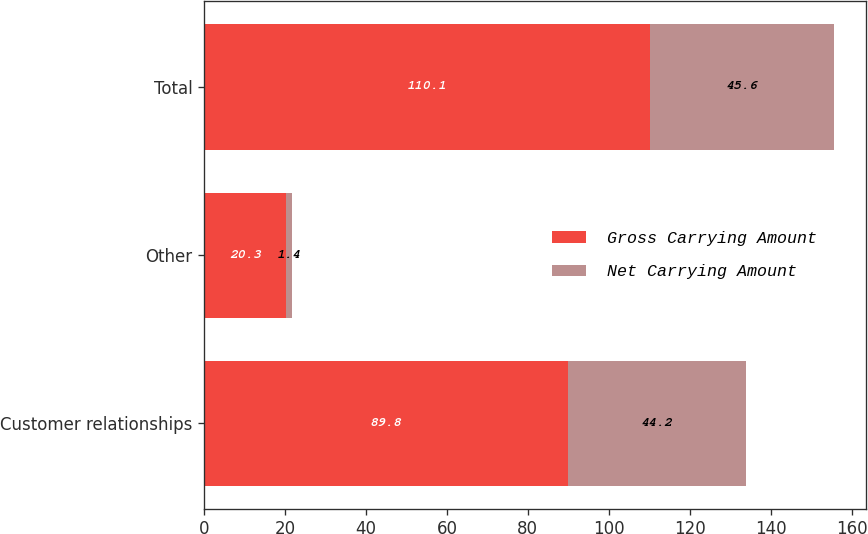Convert chart. <chart><loc_0><loc_0><loc_500><loc_500><stacked_bar_chart><ecel><fcel>Customer relationships<fcel>Other<fcel>Total<nl><fcel>Gross Carrying Amount<fcel>89.8<fcel>20.3<fcel>110.1<nl><fcel>Net Carrying Amount<fcel>44.2<fcel>1.4<fcel>45.6<nl></chart> 